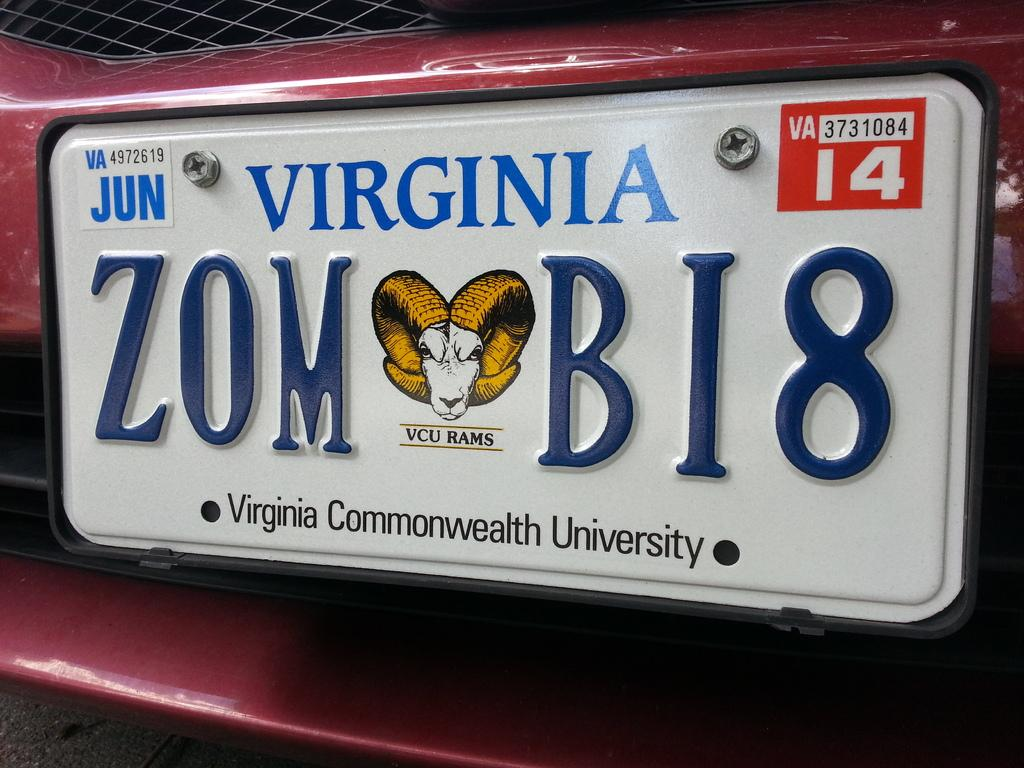Provide a one-sentence caption for the provided image. A license plate that is from Virginia that says ZOMBI8. 